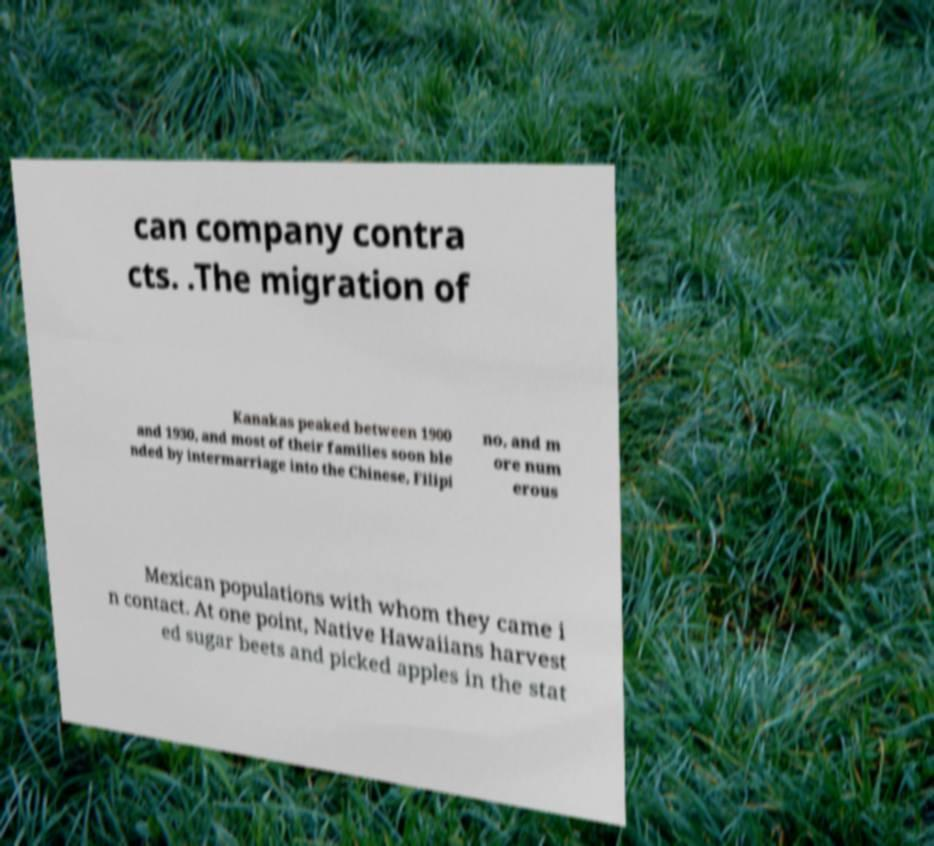For documentation purposes, I need the text within this image transcribed. Could you provide that? can company contra cts. .The migration of Kanakas peaked between 1900 and 1930, and most of their families soon ble nded by intermarriage into the Chinese, Filipi no, and m ore num erous Mexican populations with whom they came i n contact. At one point, Native Hawaiians harvest ed sugar beets and picked apples in the stat 